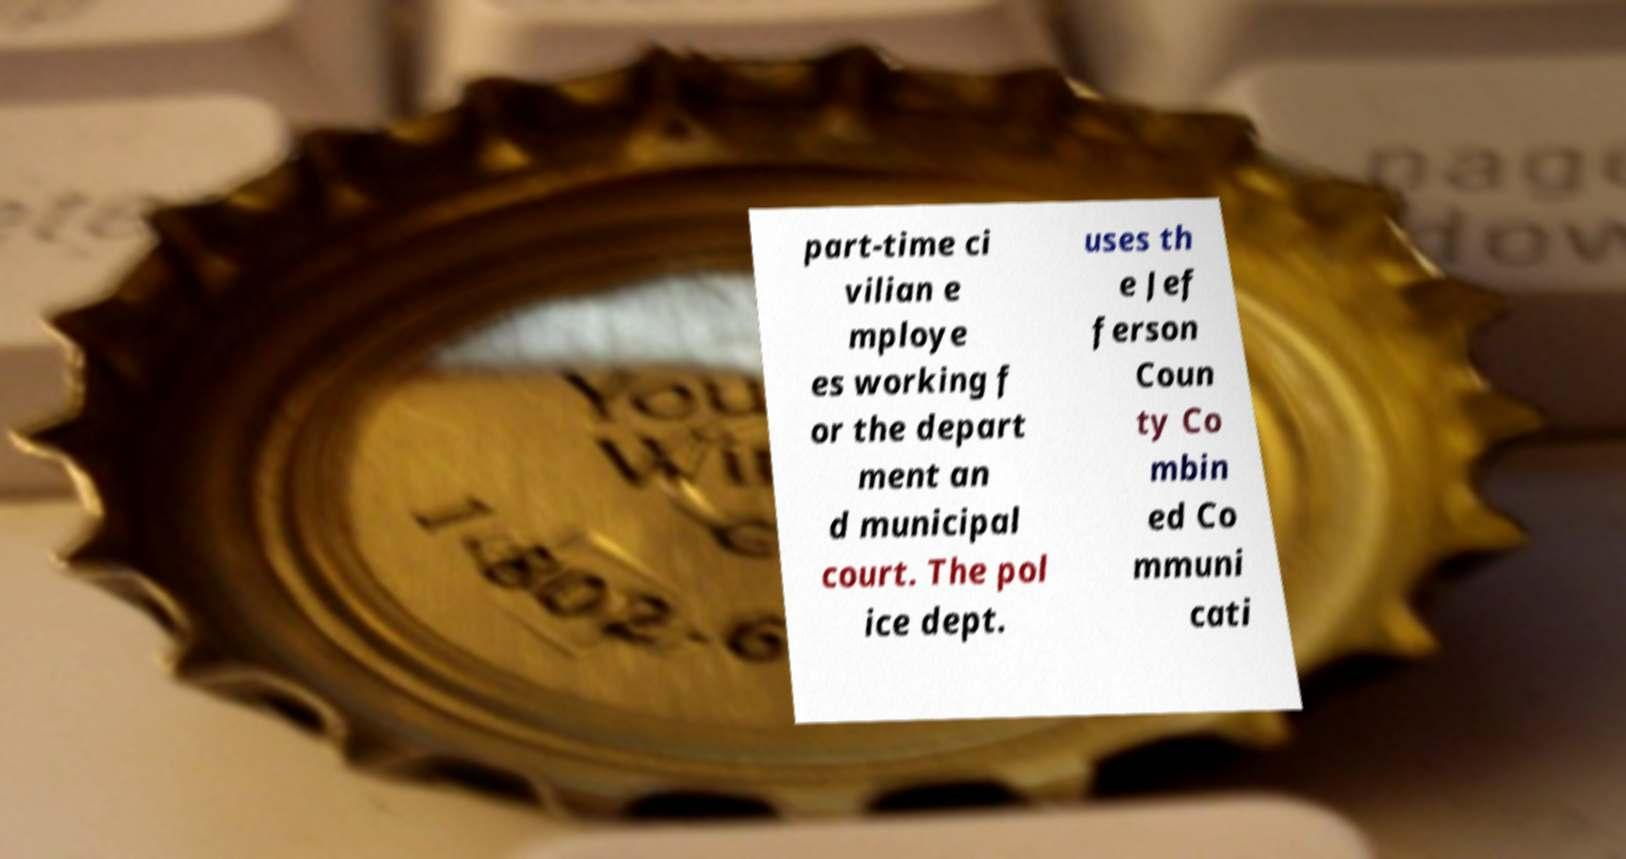I need the written content from this picture converted into text. Can you do that? part-time ci vilian e mploye es working f or the depart ment an d municipal court. The pol ice dept. uses th e Jef ferson Coun ty Co mbin ed Co mmuni cati 